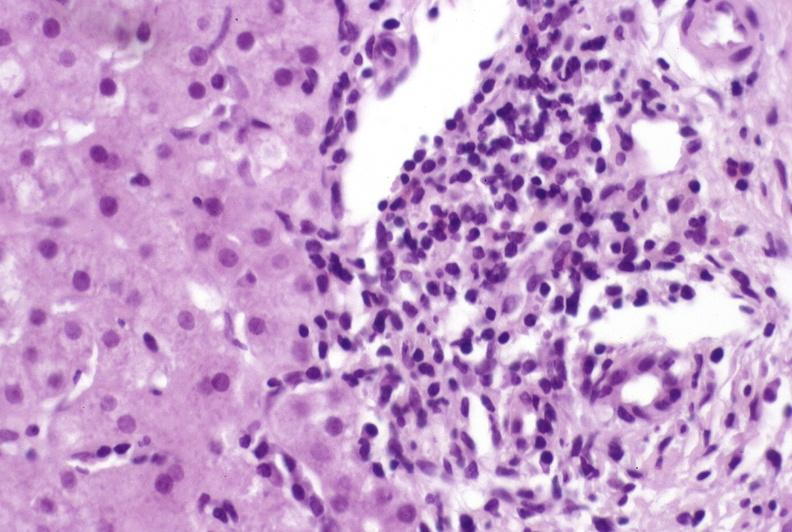does blood show primary biliary cirrhosis?
Answer the question using a single word or phrase. No 